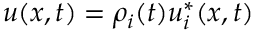<formula> <loc_0><loc_0><loc_500><loc_500>u ( x , t ) = \rho _ { i } ( t ) u _ { i } ^ { * } ( x , t )</formula> 